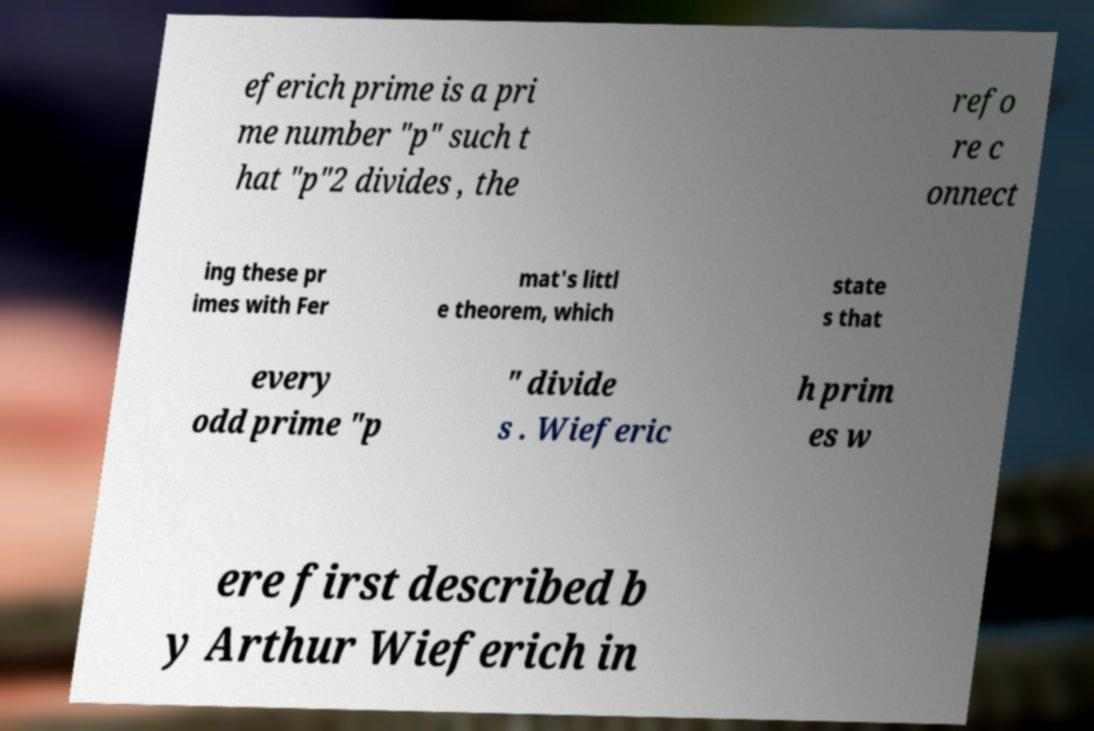Can you read and provide the text displayed in the image?This photo seems to have some interesting text. Can you extract and type it out for me? eferich prime is a pri me number "p" such t hat "p"2 divides , the refo re c onnect ing these pr imes with Fer mat's littl e theorem, which state s that every odd prime "p " divide s . Wieferic h prim es w ere first described b y Arthur Wieferich in 